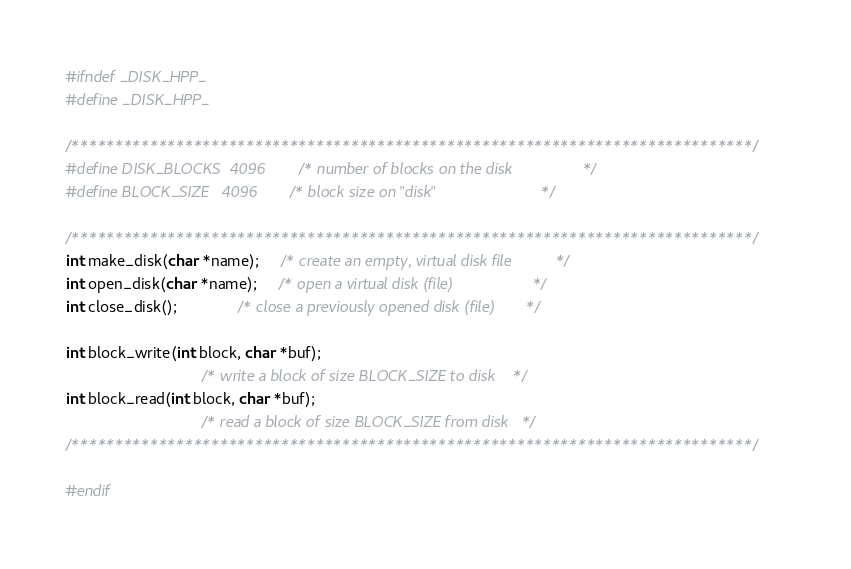Convert code to text. <code><loc_0><loc_0><loc_500><loc_500><_C++_>#ifndef _DISK_HPP_
#define _DISK_HPP_

/******************************************************************************/
#define DISK_BLOCKS  4096      /* number of blocks on the disk                */
#define BLOCK_SIZE   4096      /* block size on "disk"                        */

/******************************************************************************/
int make_disk(char *name);     /* create an empty, virtual disk file          */
int open_disk(char *name);     /* open a virtual disk (file)                  */
int close_disk();              /* close a previously opened disk (file)       */

int block_write(int block, char *buf);
                               /* write a block of size BLOCK_SIZE to disk    */
int block_read(int block, char *buf);
                               /* read a block of size BLOCK_SIZE from disk   */
/******************************************************************************/

#endif
</code> 